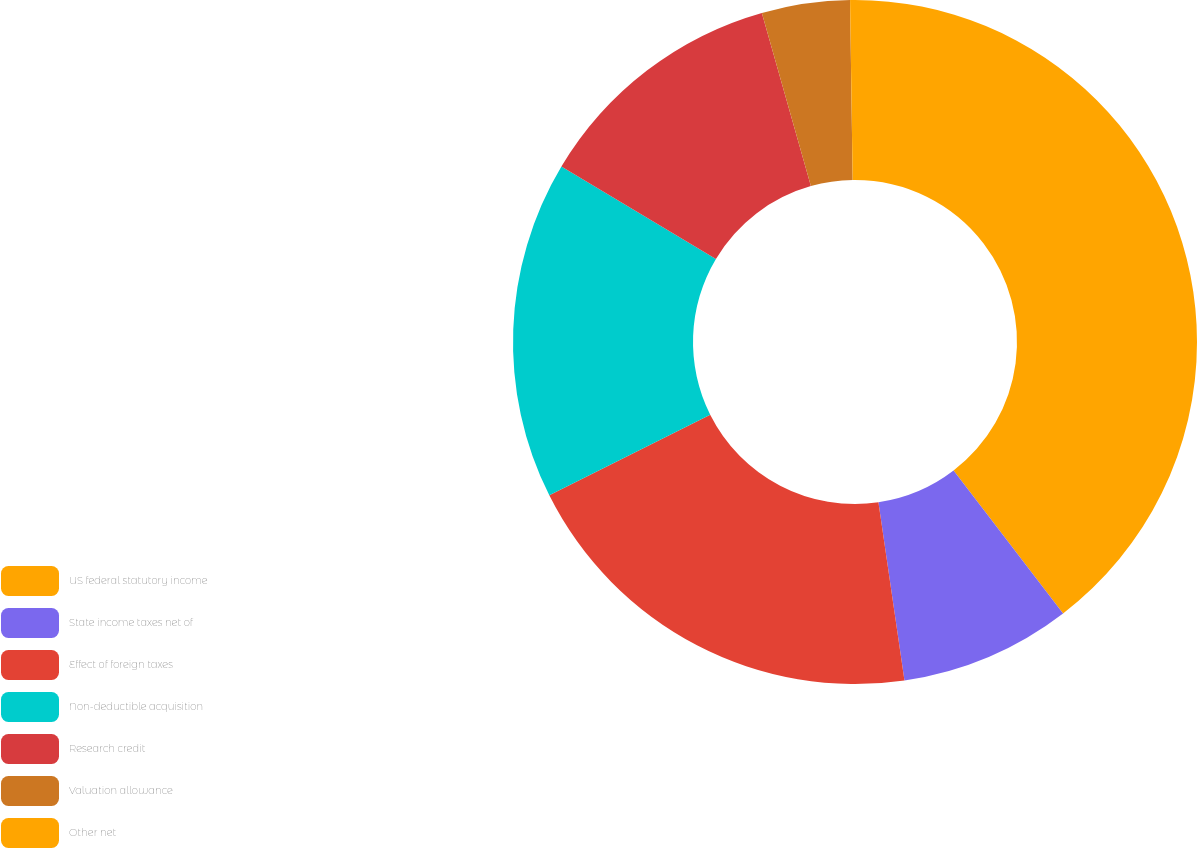Convert chart. <chart><loc_0><loc_0><loc_500><loc_500><pie_chart><fcel>US federal statutory income<fcel>State income taxes net of<fcel>Effect of foreign taxes<fcel>Non-deductible acquisition<fcel>Research credit<fcel>Valuation allowance<fcel>Other net<nl><fcel>39.59%<fcel>8.1%<fcel>19.91%<fcel>15.97%<fcel>12.04%<fcel>4.16%<fcel>0.23%<nl></chart> 